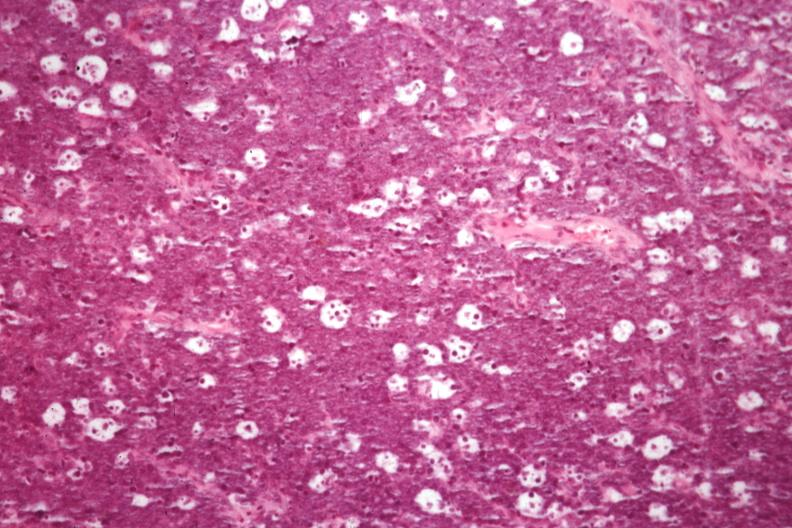s burkitts lymphoma present?
Answer the question using a single word or phrase. Yes 